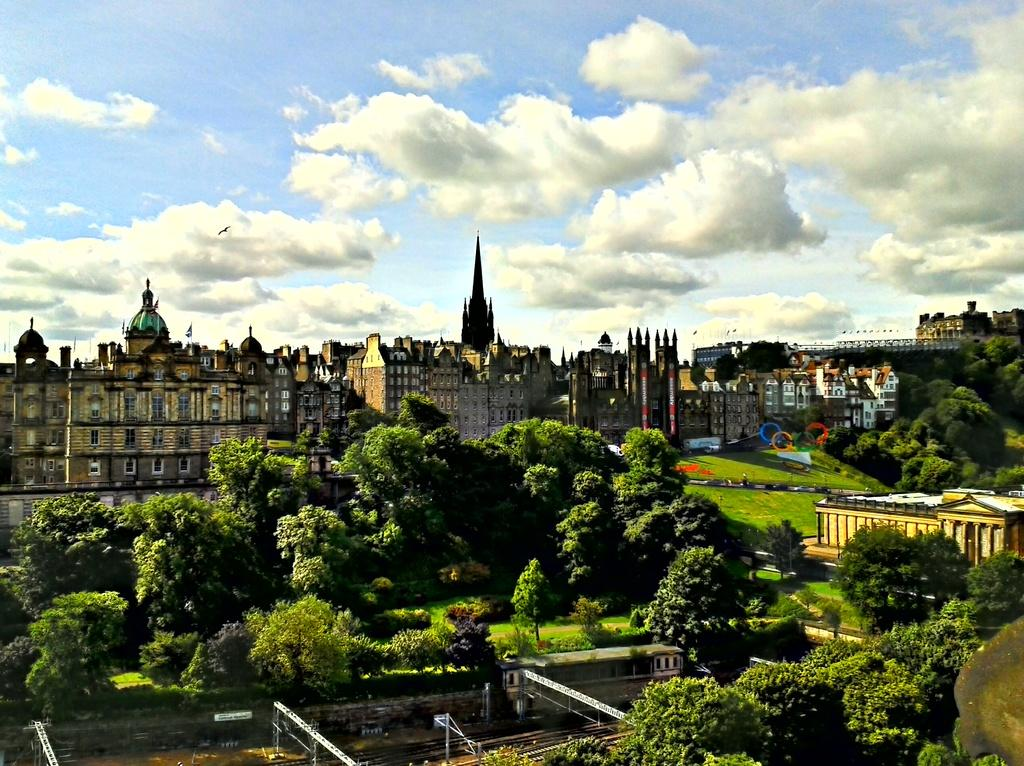What type of structures can be seen in the image? There are buildings in the image. What natural elements are present in the image? There are trees in the image. What man-made objects can be seen in the image? There are objects in the image. What architectural feature is present at the bottom of the image? There are trusses at the bottom of the image. What mode of transportation is associated with the image? There are railway tracks at the bottom of the image. What is visible at the top of the image? The sky is visible at the top of the image. How many birds are sitting on the slave in the image? There are no birds or slaves present in the image. What type of roll is being used to flatten the objects in the image? There is no roll present in the image, and the objects are not being flattened. 